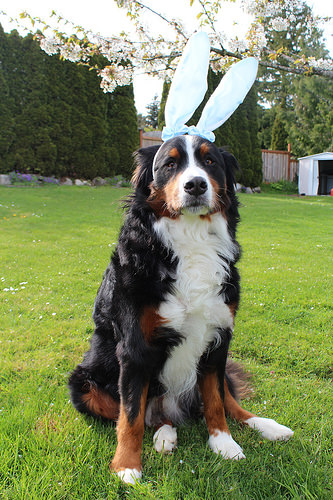<image>
Is there a bunny ears behind the dog? No. The bunny ears is not behind the dog. From this viewpoint, the bunny ears appears to be positioned elsewhere in the scene. 